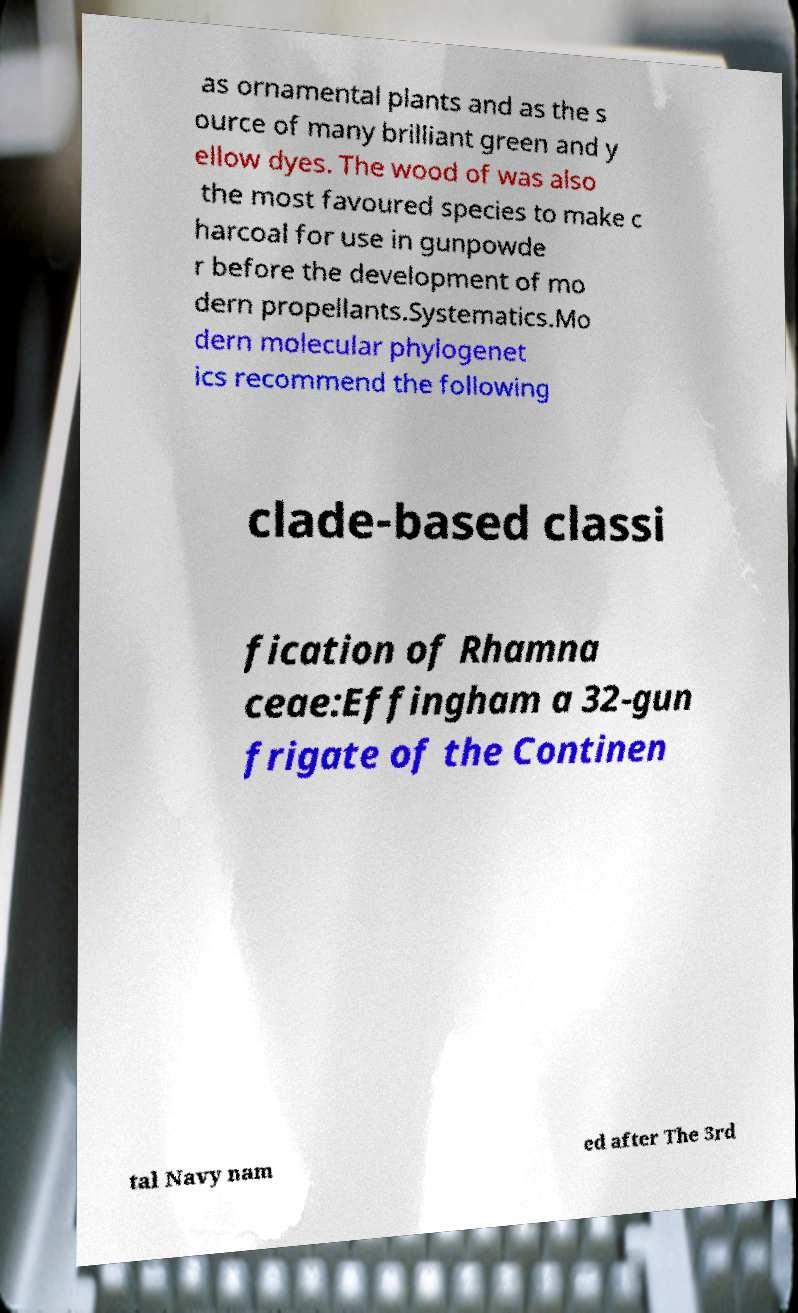Can you accurately transcribe the text from the provided image for me? as ornamental plants and as the s ource of many brilliant green and y ellow dyes. The wood of was also the most favoured species to make c harcoal for use in gunpowde r before the development of mo dern propellants.Systematics.Mo dern molecular phylogenet ics recommend the following clade-based classi fication of Rhamna ceae:Effingham a 32-gun frigate of the Continen tal Navy nam ed after The 3rd 